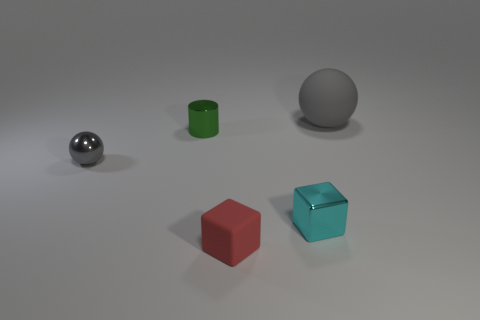Add 2 large rubber things. How many objects exist? 7 Subtract all balls. How many objects are left? 3 Add 1 red cubes. How many red cubes are left? 2 Add 2 red matte things. How many red matte things exist? 3 Subtract 0 blue balls. How many objects are left? 5 Subtract all shiny blocks. Subtract all red things. How many objects are left? 3 